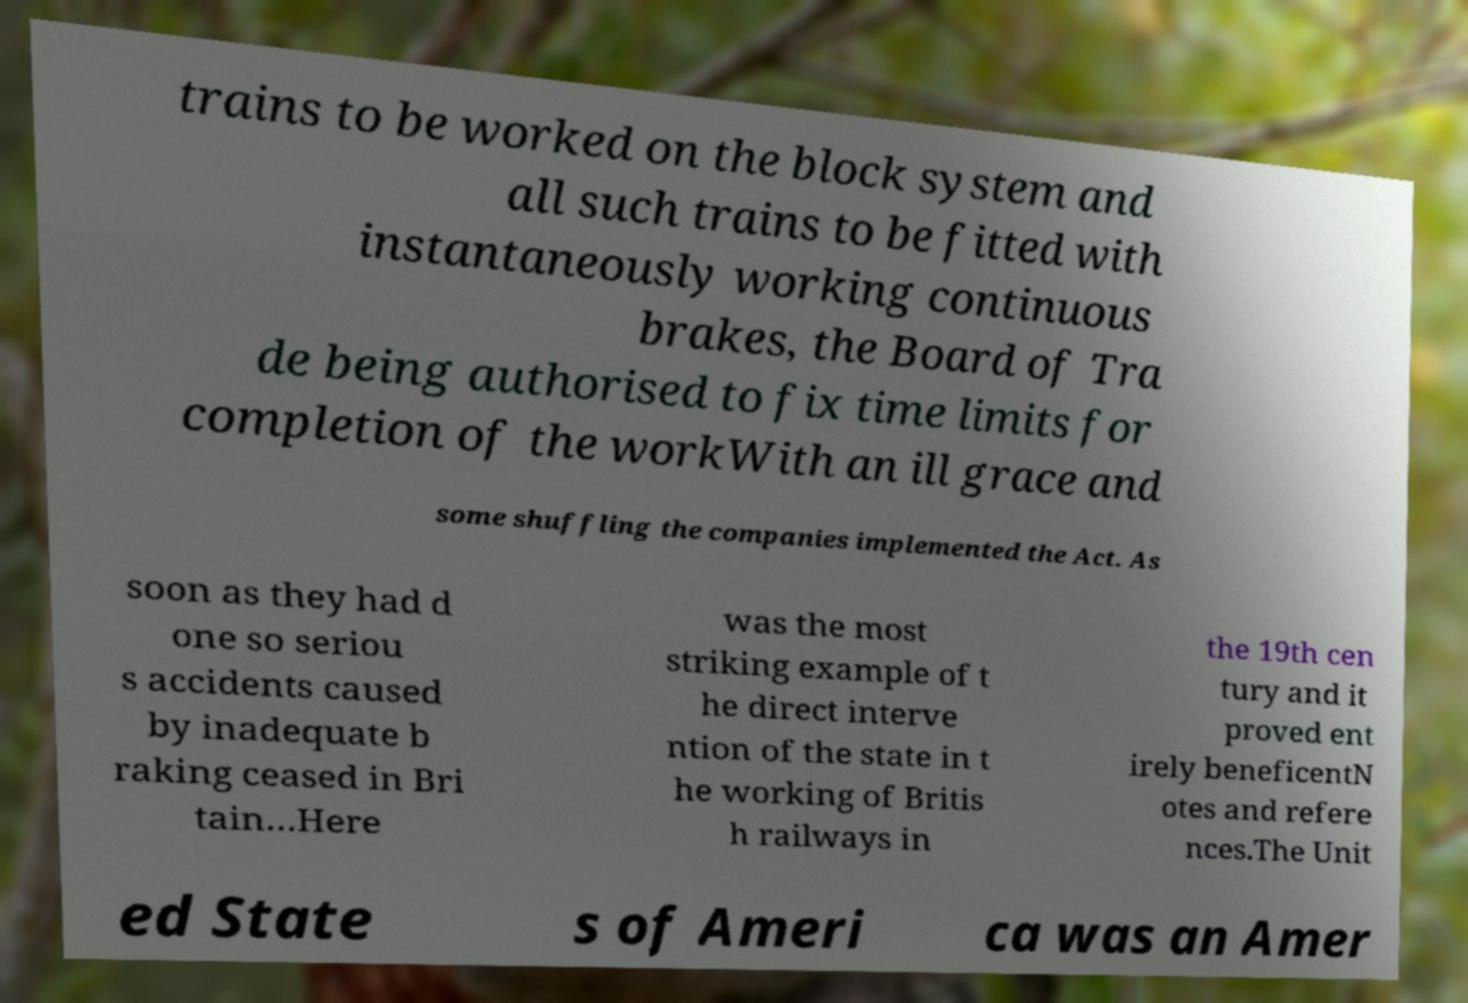Could you extract and type out the text from this image? trains to be worked on the block system and all such trains to be fitted with instantaneously working continuous brakes, the Board of Tra de being authorised to fix time limits for completion of the workWith an ill grace and some shuffling the companies implemented the Act. As soon as they had d one so seriou s accidents caused by inadequate b raking ceased in Bri tain…Here was the most striking example of t he direct interve ntion of the state in t he working of Britis h railways in the 19th cen tury and it proved ent irely beneficentN otes and refere nces.The Unit ed State s of Ameri ca was an Amer 